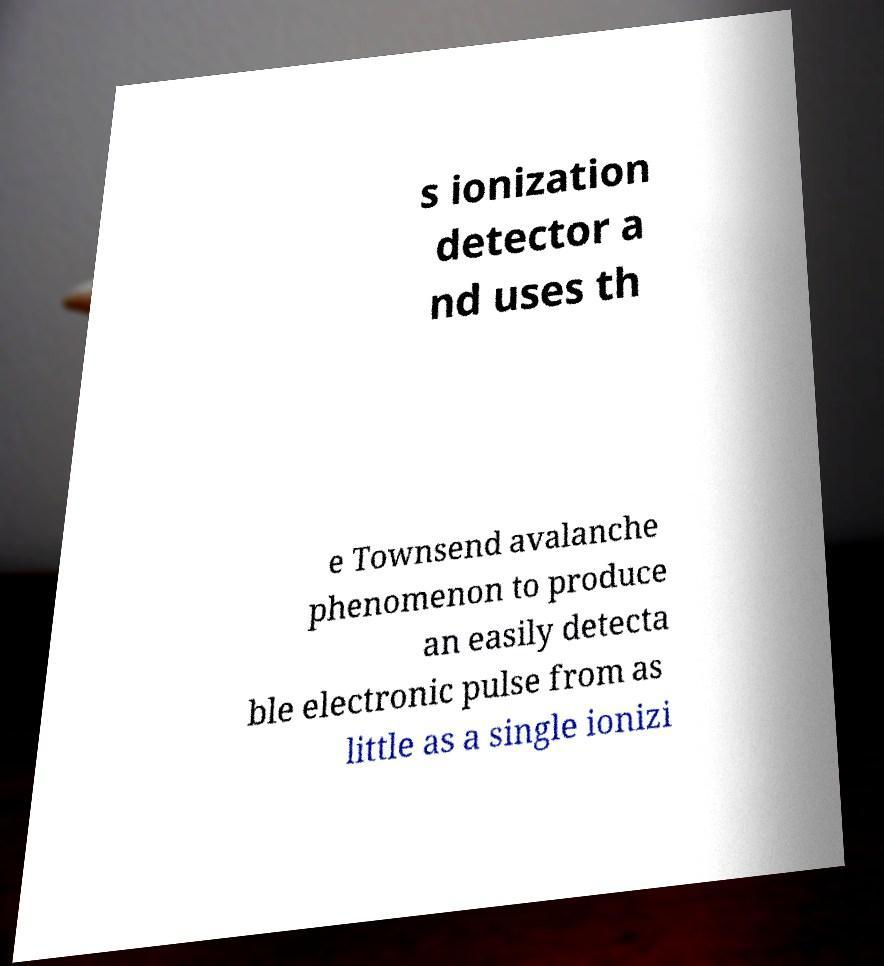Could you assist in decoding the text presented in this image and type it out clearly? s ionization detector a nd uses th e Townsend avalanche phenomenon to produce an easily detecta ble electronic pulse from as little as a single ionizi 